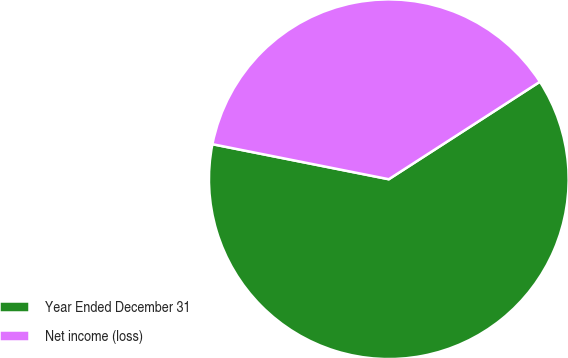Convert chart. <chart><loc_0><loc_0><loc_500><loc_500><pie_chart><fcel>Year Ended December 31<fcel>Net income (loss)<nl><fcel>62.24%<fcel>37.76%<nl></chart> 